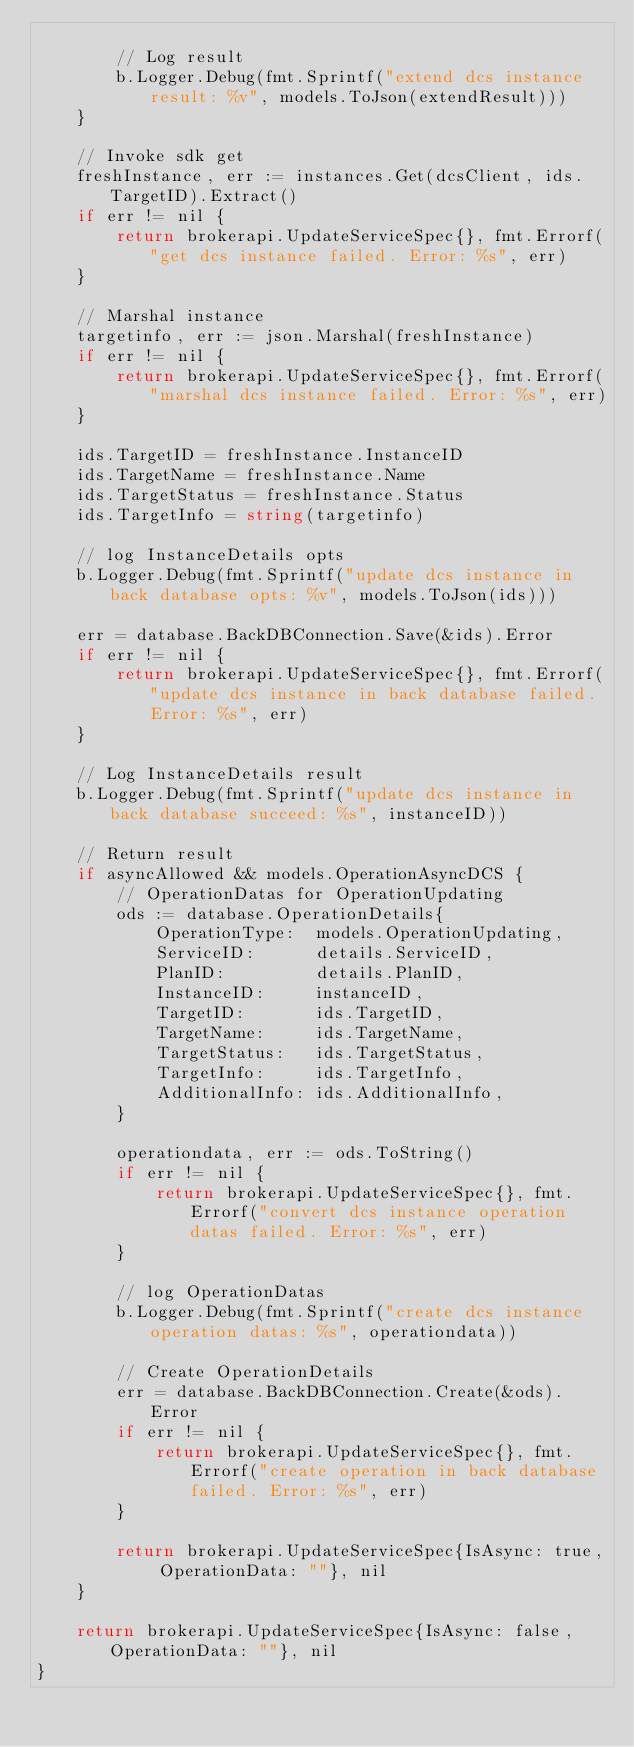<code> <loc_0><loc_0><loc_500><loc_500><_Go_>
		// Log result
		b.Logger.Debug(fmt.Sprintf("extend dcs instance result: %v", models.ToJson(extendResult)))
	}

	// Invoke sdk get
	freshInstance, err := instances.Get(dcsClient, ids.TargetID).Extract()
	if err != nil {
		return brokerapi.UpdateServiceSpec{}, fmt.Errorf("get dcs instance failed. Error: %s", err)
	}

	// Marshal instance
	targetinfo, err := json.Marshal(freshInstance)
	if err != nil {
		return brokerapi.UpdateServiceSpec{}, fmt.Errorf("marshal dcs instance failed. Error: %s", err)
	}

	ids.TargetID = freshInstance.InstanceID
	ids.TargetName = freshInstance.Name
	ids.TargetStatus = freshInstance.Status
	ids.TargetInfo = string(targetinfo)

	// log InstanceDetails opts
	b.Logger.Debug(fmt.Sprintf("update dcs instance in back database opts: %v", models.ToJson(ids)))

	err = database.BackDBConnection.Save(&ids).Error
	if err != nil {
		return brokerapi.UpdateServiceSpec{}, fmt.Errorf("update dcs instance in back database failed. Error: %s", err)
	}

	// Log InstanceDetails result
	b.Logger.Debug(fmt.Sprintf("update dcs instance in back database succeed: %s", instanceID))

	// Return result
	if asyncAllowed && models.OperationAsyncDCS {
		// OperationDatas for OperationUpdating
		ods := database.OperationDetails{
			OperationType:  models.OperationUpdating,
			ServiceID:      details.ServiceID,
			PlanID:         details.PlanID,
			InstanceID:     instanceID,
			TargetID:       ids.TargetID,
			TargetName:     ids.TargetName,
			TargetStatus:   ids.TargetStatus,
			TargetInfo:     ids.TargetInfo,
			AdditionalInfo: ids.AdditionalInfo,
		}

		operationdata, err := ods.ToString()
		if err != nil {
			return brokerapi.UpdateServiceSpec{}, fmt.Errorf("convert dcs instance operation datas failed. Error: %s", err)
		}

		// log OperationDatas
		b.Logger.Debug(fmt.Sprintf("create dcs instance operation datas: %s", operationdata))

		// Create OperationDetails
		err = database.BackDBConnection.Create(&ods).Error
		if err != nil {
			return brokerapi.UpdateServiceSpec{}, fmt.Errorf("create operation in back database failed. Error: %s", err)
		}

		return brokerapi.UpdateServiceSpec{IsAsync: true, OperationData: ""}, nil
	}

	return brokerapi.UpdateServiceSpec{IsAsync: false, OperationData: ""}, nil
}
</code> 